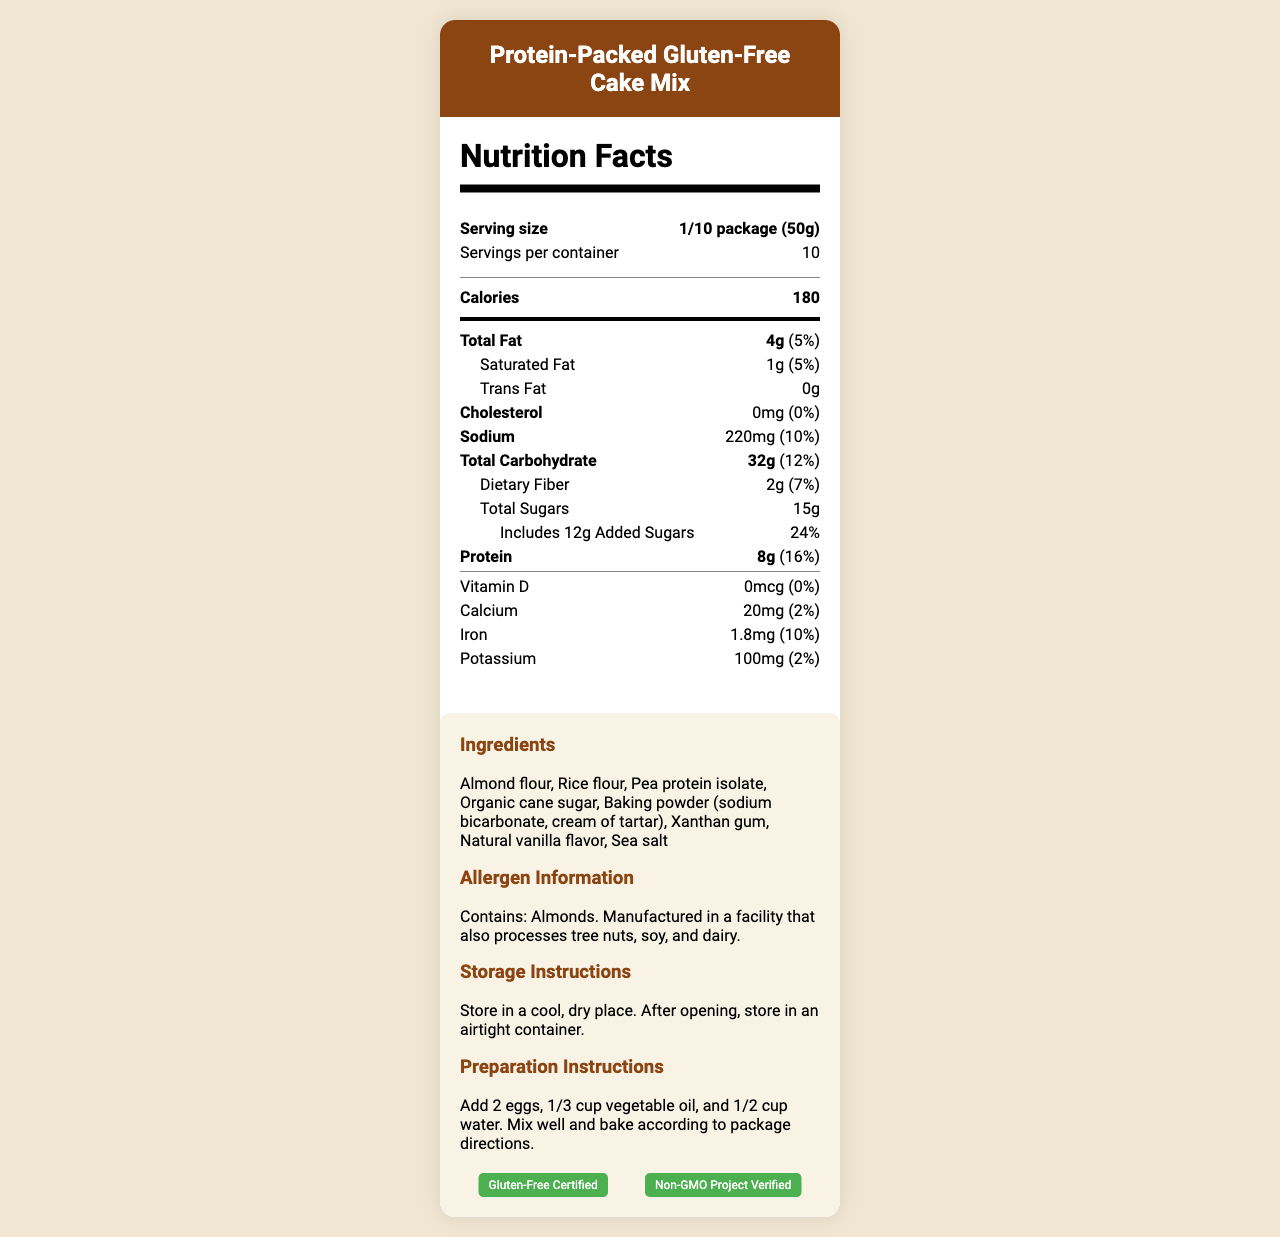what is the serving size for the Protein-Packed Gluten-Free Cake Mix? The serving size is listed in the nutrition facts section as "1/10 package (50g)."
Answer: 1/10 package (50g) How many servings per container are there? The document states that there are 10 servings per container.
Answer: 10 What is the amount of total fat per serving, and its daily percentage value? The total fat is 4g, and the daily percentage value is 5%.
Answer: 4g, 5% How much protein does one serving provide? One serving provides 8g of protein, as stated in the nutritional information.
Answer: 8g What are the ingredients in the cake mix? The ingredients are listed in the additional information section.
Answer: Almond flour, Rice flour, Pea protein isolate, Organic cane sugar, Baking powder (sodium bicarbonate, cream of tartar), Xanthan gum, Natural vanilla flavor, Sea salt What are the preparation instructions for the cake mix? The preparation instructions are provided in the additional information section.
Answer: Add 2 eggs, 1/3 cup vegetable oil, and 1/2 cup water. Mix well and bake according to package directions. How many grams of added sugars are in one serving, and what is its daily value percentage? The label indicates that one serving of cake mix includes 12g of added sugars, which is 24% of the daily value.
Answer: 12g, 24% What certifications does the cake mix have? A. Organic B. Gluten-Free Certified C. Fair Trade Certified D. Non-GMO Project Verified The document indicates that the cake mix is Gluten-Free Certified and Non-GMO Project Verified.
Answer: B, D Which of the following diets is the cake mix suitable for? (Choose all that apply) I. Vegan diets II. High-protein diets III. Nut-free diets IV. Vegetarian diets The cake mix is suitable for high-protein diets and vegetarian diets.
Answer: II and IV True or False: The cake mix is manufactured in a facility that processes tree nuts. The allergen information confirms that it is manufactured in a facility that processes tree nuts.
Answer: True Summarize the main idea of the document. The summary encompasses the main sections and key points found within the document, giving a comprehensive overview of its content.
Answer: The document provides detailed nutritional facts, ingredient information, allergen information, storage instructions, preparation instructions, and certifications for the Protein-Packed Gluten-Free Cake Mix. It highlights the key attributes like being gluten-free, high-protein, and suitable for certain diets while providing essential details for consumers. What is the exact weight of the entire package of the cake mix? The net weight of the product is given as 500g (17.6 oz) in the additional information section.
Answer: 500g (17.6 oz) How much iron is in one serving of the cake mix, and what is its daily percentage value? The iron content per serving is 1.8mg, which is 10% of the daily value.
Answer: 1.8mg, 10% Can this cake mix be included in a vegan diet? The additional information clearly states that it is not suitable for vegan diets.
Answer: No List all types of fat found in the cake mix per serving. The nutrition facts label lists total fat (4g), saturated fat (1g), and trans fat (0g).
Answer: Total Fat, Saturated Fat, Trans Fat Which ingredient in the cake mix might cause an allergic reaction for someone allergic to nuts? The allergen information indicates that the product contains almonds, and the ingredient list specifies almond flour.
Answer: Almond flour What is the daily percentage value of the dietary fiber in one serving? The document states that dietary fiber is 2g per serving, which corresponds to 7% of the daily value.
Answer: 7% What is the brand name of this specialty cake mix? The additional information specifies the brand as Cakecraft Pro Series.
Answer: Cakecraft Pro Series Does this cake mix contain any vitamin D? The nutrition facts section shows that the amount of vitamin D is 0mcg with a daily value percentage of 0%.
Answer: No What is the exact amount of calcium in one serving? The document states that one serving contains 20mg of calcium.
Answer: 20mg Is this cake mix suitable for people with nut allergies? The allergen information notes that the product contains almonds and is manufactured in a facility that also processes tree nuts, making it unsuitable for people with nut allergies.
Answer: No What are the storage instructions for the cake mix? The storage instructions are provided under the additional information section.
Answer: Store in a cool, dry place. After opening, store in an airtight container. 